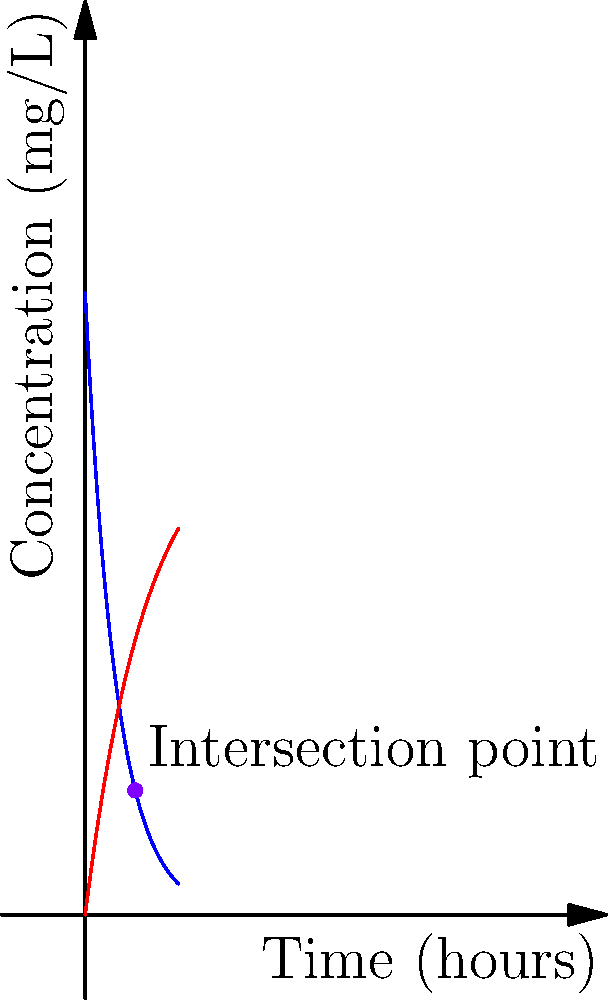In a clinical trial, two drugs are administered to participants. Drug A follows an exponential decay model with initial concentration of 100 mg/L and decay rate of 0.2 per hour. Drug B follows an absorption model with maximum concentration of 80 mg/L and absorption rate of 0.1 per hour. The concentration curves for both drugs are shown in the graph.

The concentration of Drug A is given by $C_A(t) = 100e^{-0.2t}$, and the concentration of Drug B is given by $C_B(t) = 80(1-e^{-0.1t})$, where $t$ is time in hours.

At what time (in hours) do the concentrations of Drug A and Drug B intersect, and what is the concentration (in mg/L) at this intersection point? Round your answers to two decimal places. To find the intersection point, we need to solve the equation:

$C_A(t) = C_B(t)$

$100e^{-0.2t} = 80(1-e^{-0.1t})$

$100e^{-0.2t} = 80 - 80e^{-0.1t}$

$100e^{-0.2t} + 80e^{-0.1t} = 80$

$100e^{-0.2t} + 80e^{-0.1t} - 80 = 0$

This equation cannot be solved analytically, so we need to use numerical methods. Using a graphing calculator or computer software, we can find that the solution is approximately:

$t \approx 8.05$ hours

To find the concentration at this time, we can substitute this value into either equation:

$C_A(8.05) = 100e^{-0.2(8.05)} \approx 20.00$ mg/L

$C_B(8.05) = 80(1-e^{-0.1(8.05)}) \approx 20.00$ mg/L

Therefore, the drugs intersect at approximately 8.05 hours, with a concentration of about 20.00 mg/L.
Answer: 8.05 hours, 20.00 mg/L 